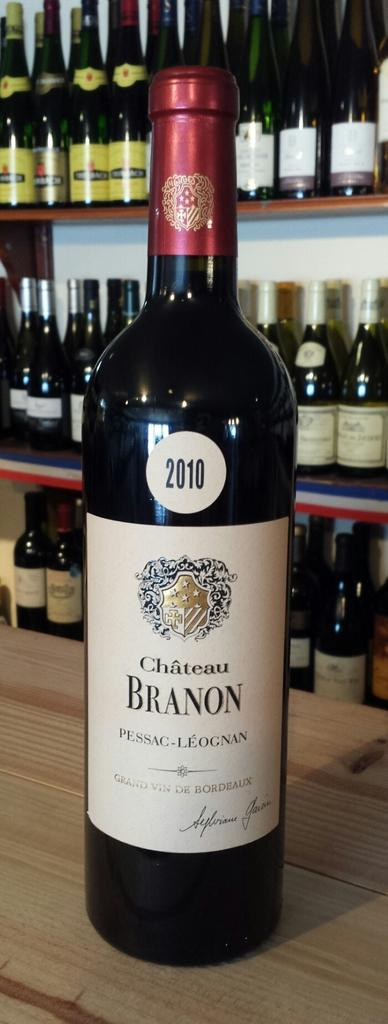<image>
Describe the image concisely. a bottle of chateau branon from 2010 sitting on a bar 